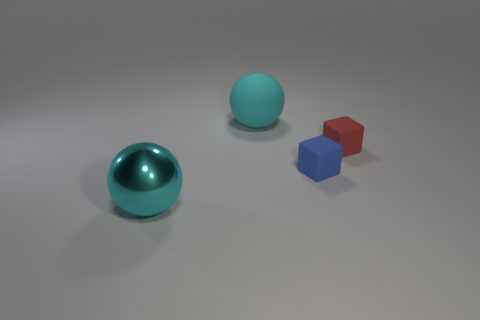Add 4 tiny red rubber blocks. How many objects exist? 8 Subtract 0 brown cylinders. How many objects are left? 4 Subtract all blue matte balls. Subtract all red objects. How many objects are left? 3 Add 2 small red blocks. How many small red blocks are left? 3 Add 2 tiny red metal balls. How many tiny red metal balls exist? 2 